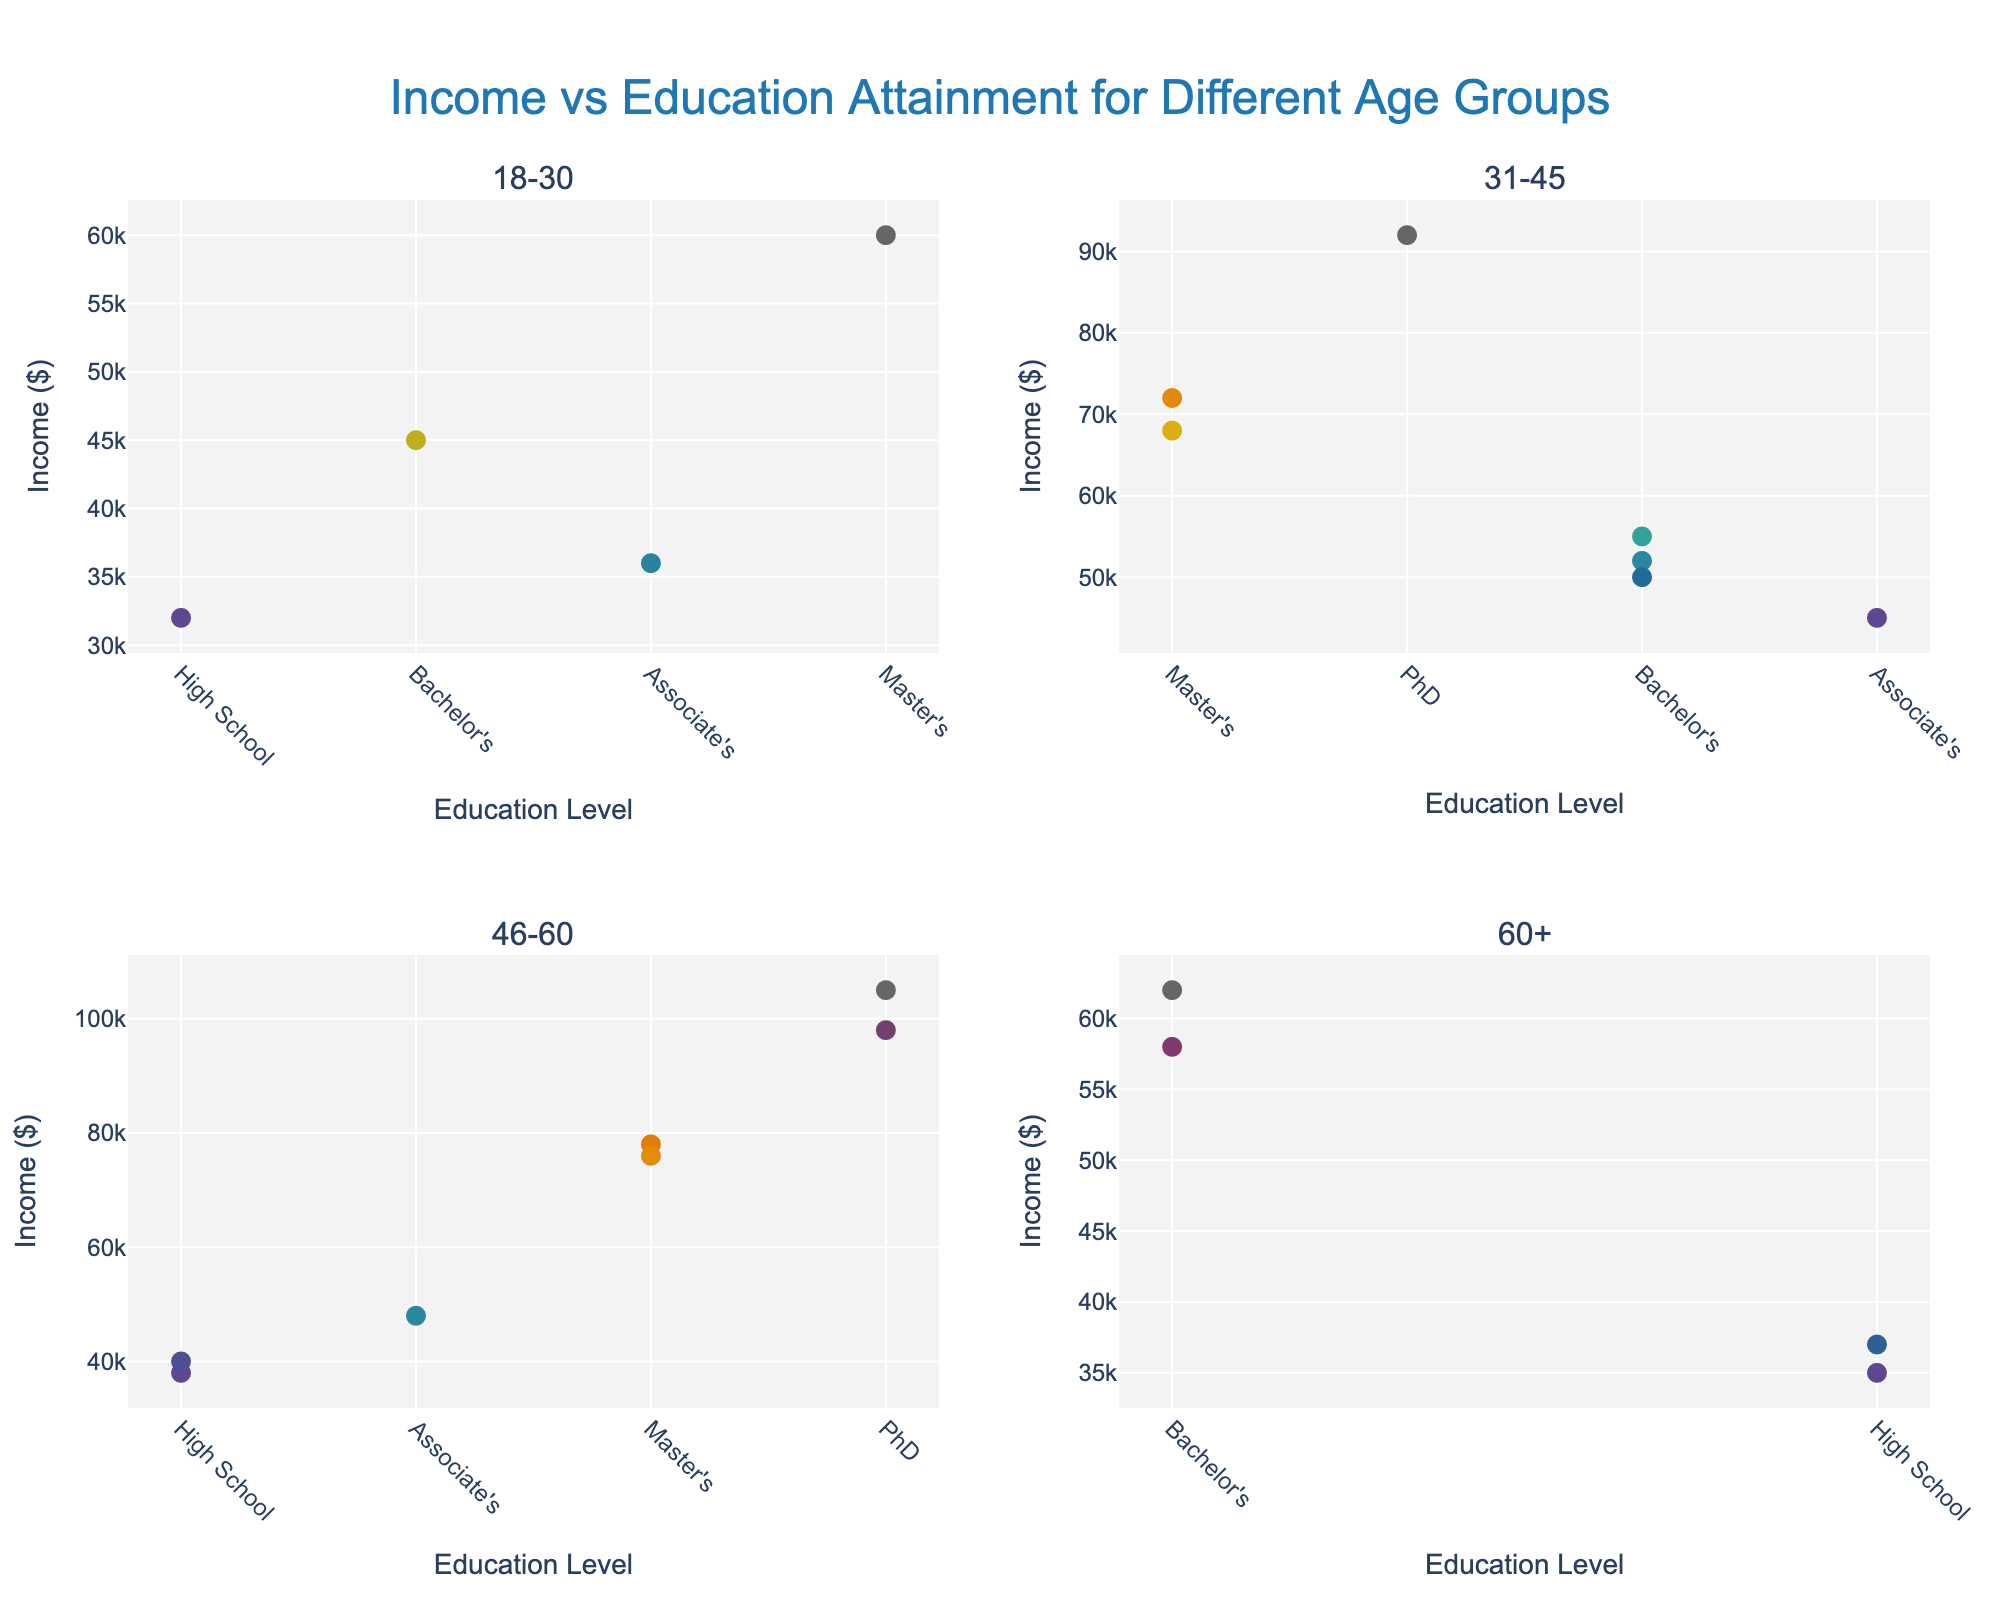What's the title of the figure? The title is displayed at the top center of the figure. It shows context about what the figure represents.
Answer: Income vs Education Attainment for Different Age Groups How many subplots are there in this figure? The figure appears to be divided into distinct sections, each representing a different age group. By counting these sections, we can determine the number of subplots.
Answer: 4 Which age group shows the highest income data point? Look at the subgroup scatter plots and identify the one that has the highest y-axis value (Income). It's in the subplot for the age group of 46-60.
Answer: 46-60 What's the average income of women aged 31-45 with a Master's degree? In the 31-45 age group subplot, locate the data points labeled with "Master's". The incomes are 68000 and 72000. The average is calculated as (68000 + 72000) / 2.
Answer: 70000 What education level tends to have the lowest income in the 60+ age group? Observe the data points in the 60+ age group subplot and identify the education level associated with the lowest y-axis values (Income).
Answer: High School How does the income vary across different education levels for the 18-30 age group? Examine the scatter plot for the 18-30 age group, and compare the income levels (y-axis) associated with different education levels (x-axis: High School, Associate's, Bachelor's, Master's).
Answer: Associate's < High School < Bachelor's < Master's In which age group does a Bachelor's degree correlate with the lowest income level? For each age group subplot, identify the data points labeled "Bachelor's" and find which group has the lowest y-axis value.
Answer: 31-45 What's the range of incomes for women aged 46-60 with a PhD? In the 46-60 age group subplot, locate the data points labeled with "PhD". They are 98000 and 105000. The range is calculated by subtracting the smallest value from the largest value.
Answer: 7000 Which age group shows more variety of incomes for women with a Bachelor's degree? Compare the range of incomes among data points labeled with "Bachelor's" across all age group subplots. Look at the minimum and maximum incomes for Bachelor's degree holders within each group.
Answer: 60+ What's the median income for women aged 18-30? For the 18-30 age group subplot, list all the y-values (Incomes), arrange them in order, and find the middle value. For six data points, the median is the average of the 3rd and 4th values. (32000, 36000, 45000, 45000, 60000) The median is (45000+45000)/2.
Answer: 45000 